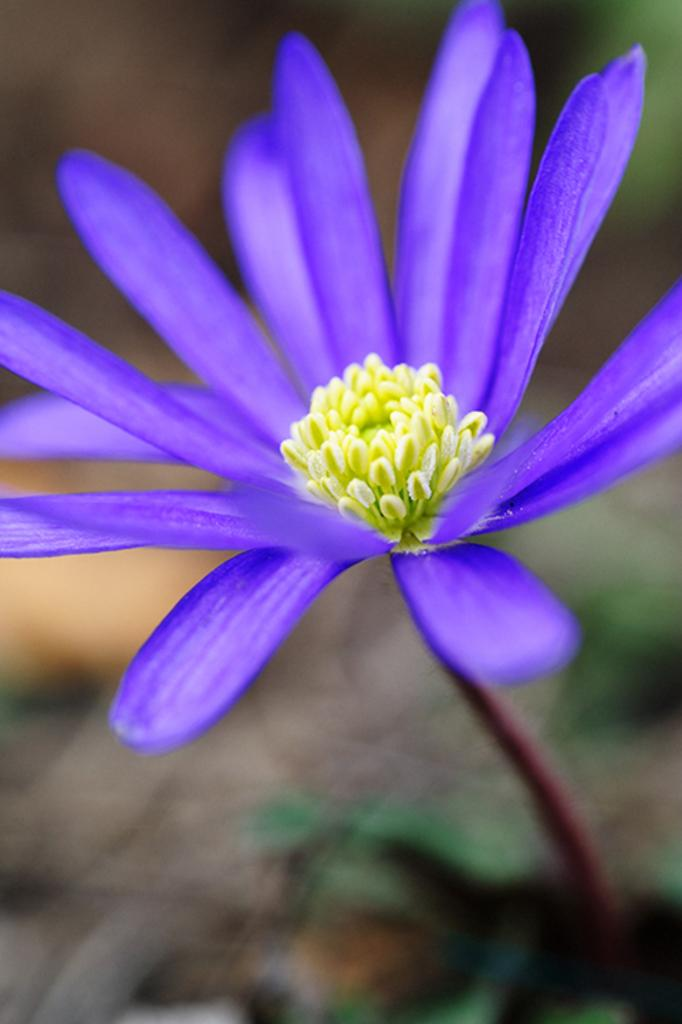What is the main subject of the image? There is a flower in the image. What color is the flower? The flower is violet in color. Can you describe the background of the image? The background of the image is blurred. What type of cabbage can be seen in the image? There is no cabbage present in the image; it features a violet flower. How many beads are used to decorate the butter in the image? There is no butter or beads present in the image. 